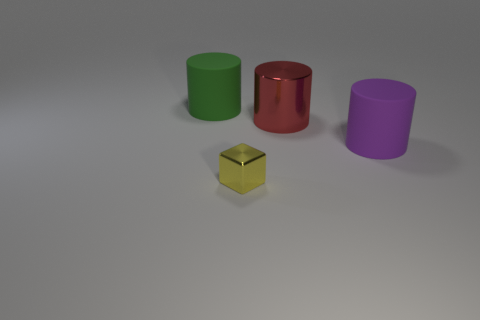There is a small thing; what shape is it?
Provide a short and direct response. Cube. What is the material of the other green thing that is the same shape as the big shiny thing?
Make the answer very short. Rubber. How many brown shiny balls have the same size as the purple cylinder?
Give a very brief answer. 0. Is there a object to the right of the rubber cylinder that is behind the large purple cylinder?
Your answer should be very brief. Yes. How many yellow things are small cubes or small metal spheres?
Your answer should be compact. 1. What color is the small metal thing?
Make the answer very short. Yellow. What size is the thing that is made of the same material as the cube?
Your answer should be compact. Large. How many other metal things have the same shape as the yellow shiny object?
Keep it short and to the point. 0. Are there any other things that are the same size as the yellow metal thing?
Offer a very short reply. No. How big is the matte cylinder that is to the left of the object that is in front of the large purple rubber cylinder?
Your answer should be compact. Large. 